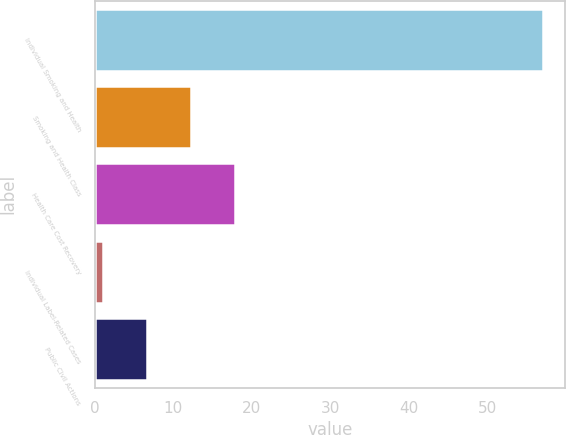Convert chart. <chart><loc_0><loc_0><loc_500><loc_500><bar_chart><fcel>Individual Smoking and Health<fcel>Smoking and Health Class<fcel>Health Care Cost Recovery<fcel>Individual Label-Related Cases<fcel>Public Civil Actions<nl><fcel>57<fcel>12.2<fcel>17.8<fcel>1<fcel>6.6<nl></chart> 